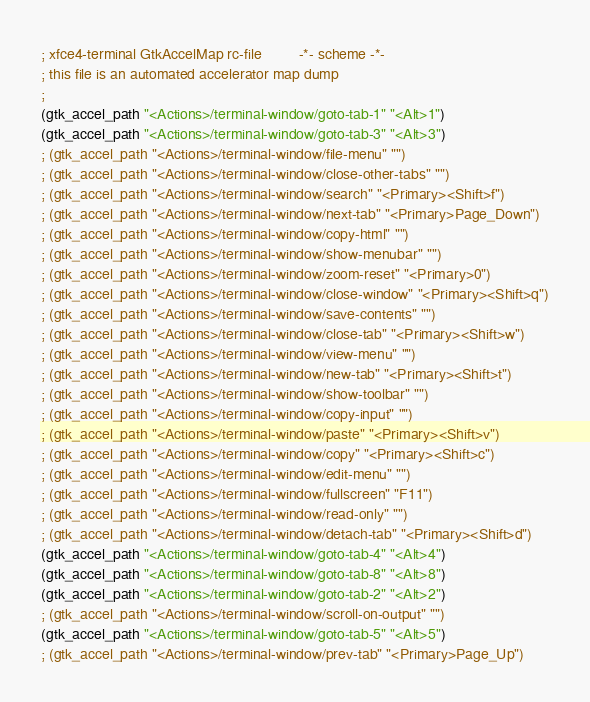Convert code to text. <code><loc_0><loc_0><loc_500><loc_500><_Scheme_>; xfce4-terminal GtkAccelMap rc-file         -*- scheme -*-
; this file is an automated accelerator map dump
;
(gtk_accel_path "<Actions>/terminal-window/goto-tab-1" "<Alt>1")
(gtk_accel_path "<Actions>/terminal-window/goto-tab-3" "<Alt>3")
; (gtk_accel_path "<Actions>/terminal-window/file-menu" "")
; (gtk_accel_path "<Actions>/terminal-window/close-other-tabs" "")
; (gtk_accel_path "<Actions>/terminal-window/search" "<Primary><Shift>f")
; (gtk_accel_path "<Actions>/terminal-window/next-tab" "<Primary>Page_Down")
; (gtk_accel_path "<Actions>/terminal-window/copy-html" "")
; (gtk_accel_path "<Actions>/terminal-window/show-menubar" "")
; (gtk_accel_path "<Actions>/terminal-window/zoom-reset" "<Primary>0")
; (gtk_accel_path "<Actions>/terminal-window/close-window" "<Primary><Shift>q")
; (gtk_accel_path "<Actions>/terminal-window/save-contents" "")
; (gtk_accel_path "<Actions>/terminal-window/close-tab" "<Primary><Shift>w")
; (gtk_accel_path "<Actions>/terminal-window/view-menu" "")
; (gtk_accel_path "<Actions>/terminal-window/new-tab" "<Primary><Shift>t")
; (gtk_accel_path "<Actions>/terminal-window/show-toolbar" "")
; (gtk_accel_path "<Actions>/terminal-window/copy-input" "")
; (gtk_accel_path "<Actions>/terminal-window/paste" "<Primary><Shift>v")
; (gtk_accel_path "<Actions>/terminal-window/copy" "<Primary><Shift>c")
; (gtk_accel_path "<Actions>/terminal-window/edit-menu" "")
; (gtk_accel_path "<Actions>/terminal-window/fullscreen" "F11")
; (gtk_accel_path "<Actions>/terminal-window/read-only" "")
; (gtk_accel_path "<Actions>/terminal-window/detach-tab" "<Primary><Shift>d")
(gtk_accel_path "<Actions>/terminal-window/goto-tab-4" "<Alt>4")
(gtk_accel_path "<Actions>/terminal-window/goto-tab-8" "<Alt>8")
(gtk_accel_path "<Actions>/terminal-window/goto-tab-2" "<Alt>2")
; (gtk_accel_path "<Actions>/terminal-window/scroll-on-output" "")
(gtk_accel_path "<Actions>/terminal-window/goto-tab-5" "<Alt>5")
; (gtk_accel_path "<Actions>/terminal-window/prev-tab" "<Primary>Page_Up")</code> 